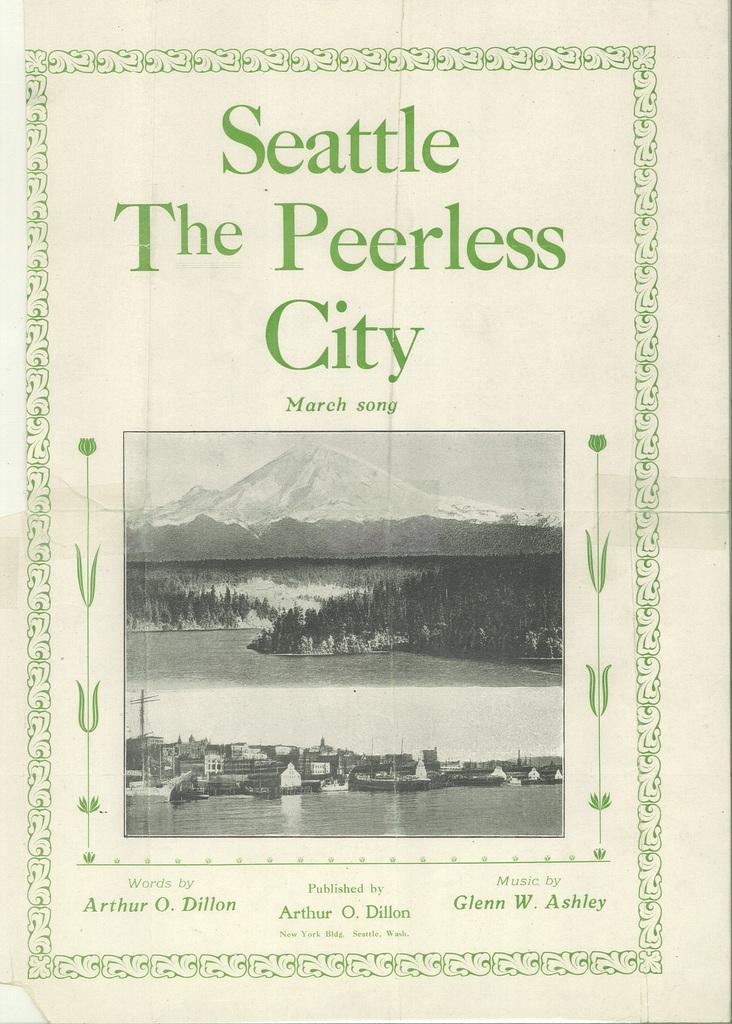Describe this image in one or two sentences. In this picture we can see a poster with some image and text, In the image we can see some buildings, trees, mountains, plants, water and the sky. 